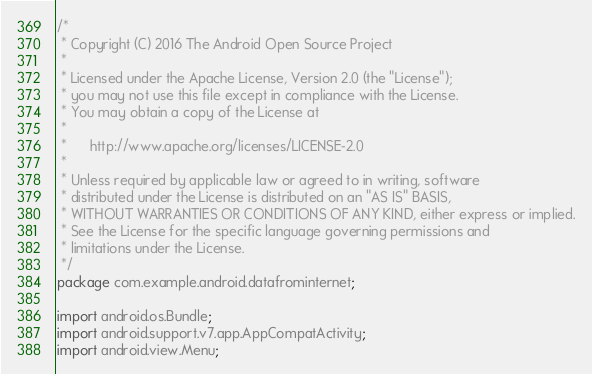<code> <loc_0><loc_0><loc_500><loc_500><_Java_>/*
 * Copyright (C) 2016 The Android Open Source Project
 *
 * Licensed under the Apache License, Version 2.0 (the "License");
 * you may not use this file except in compliance with the License.
 * You may obtain a copy of the License at
 *
 *      http://www.apache.org/licenses/LICENSE-2.0
 *
 * Unless required by applicable law or agreed to in writing, software
 * distributed under the License is distributed on an "AS IS" BASIS,
 * WITHOUT WARRANTIES OR CONDITIONS OF ANY KIND, either express or implied.
 * See the License for the specific language governing permissions and
 * limitations under the License.
 */
package com.example.android.datafrominternet;

import android.os.Bundle;
import android.support.v7.app.AppCompatActivity;
import android.view.Menu;</code> 